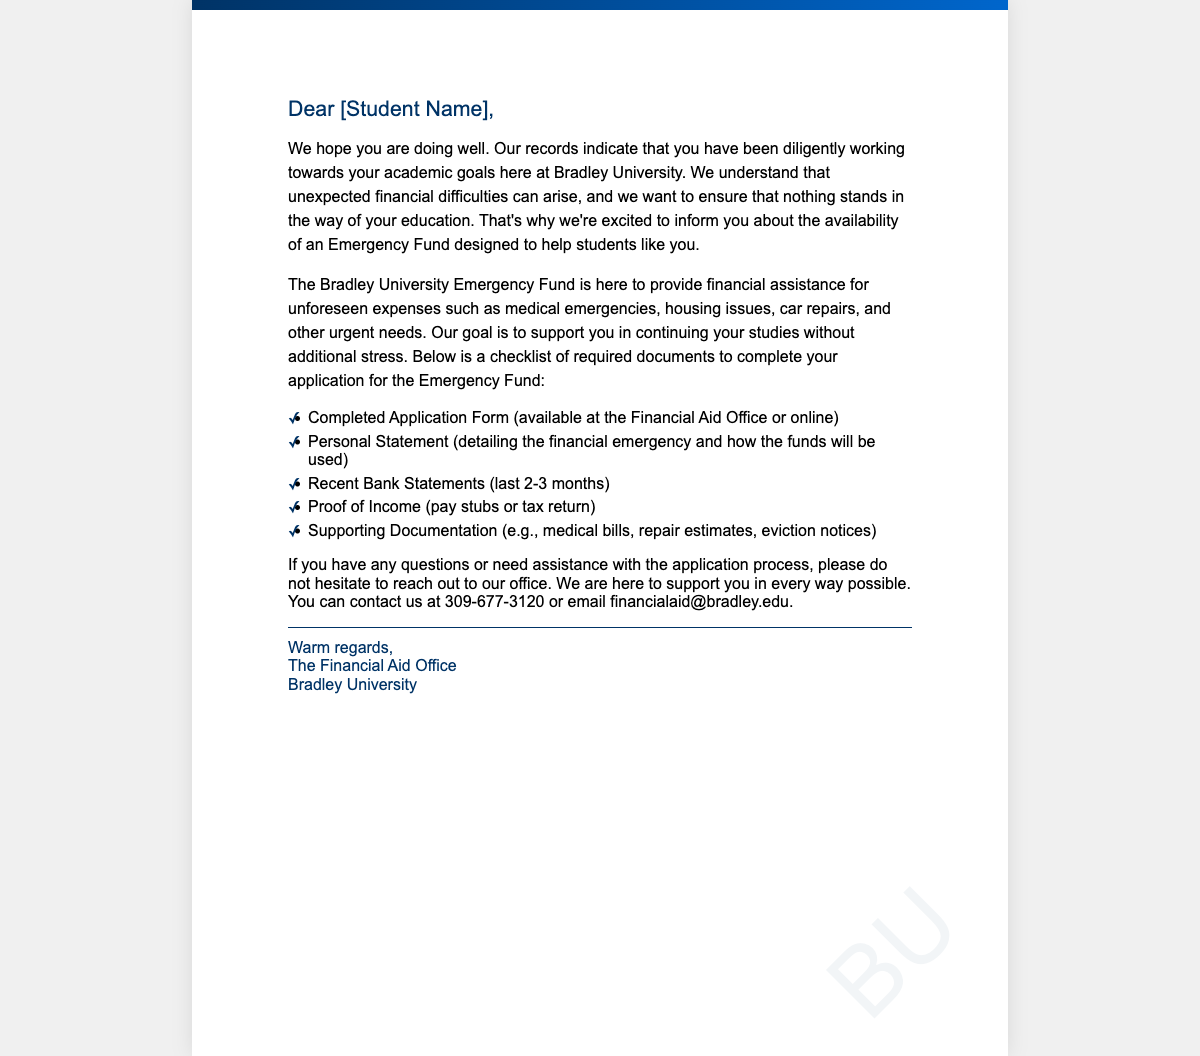What is the purpose of the Emergency Fund? The Emergency Fund is designed to help students with unforeseen expenses such as medical emergencies, housing issues, car repairs, and other urgent needs.
Answer: financial assistance for unforeseen expenses What is one document required for the Emergency Fund application? The document checklist includes several items, one of which is a completed application form.
Answer: Completed Application Form How can students contact the Financial Aid Office? The document provides contact information, specifying a phone number and an email address for inquiries.
Answer: 309-677-3120 or financialaid@bradley.edu What is the color used in the card's header? The color of the header text is specified in the card's style as a dark blue shade.
Answer: #003366 How many recent months of bank statements are requested? The checklist specifies that students should provide bank statements for a certain duration, which is defined in the document.
Answer: last 2-3 months What type of specific statement is needed from the student? The checklist includes a requirement for a personal statement detailing a specific situation related to financial need.
Answer: Personal Statement What is the first step to apply for the Emergency Fund? The document indicates that a completed application form is required as the initial step in the application process.
Answer: Completed Application Form What is the sentiment expressed towards the student in the greeting card? The tone of the message aims to show support and encouragement toward the student's academic journey.
Answer: support What is the intended audience of this greeting card? The card is specifically addressed to students at Bradley University.
Answer: students 